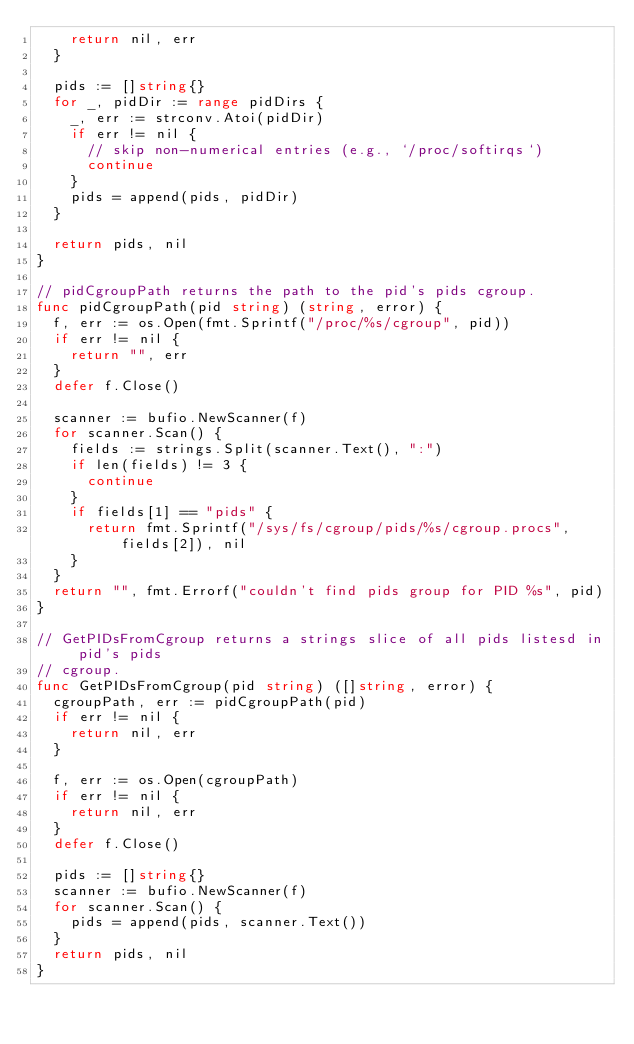<code> <loc_0><loc_0><loc_500><loc_500><_Go_>		return nil, err
	}

	pids := []string{}
	for _, pidDir := range pidDirs {
		_, err := strconv.Atoi(pidDir)
		if err != nil {
			// skip non-numerical entries (e.g., `/proc/softirqs`)
			continue
		}
		pids = append(pids, pidDir)
	}

	return pids, nil
}

// pidCgroupPath returns the path to the pid's pids cgroup.
func pidCgroupPath(pid string) (string, error) {
	f, err := os.Open(fmt.Sprintf("/proc/%s/cgroup", pid))
	if err != nil {
		return "", err
	}
	defer f.Close()

	scanner := bufio.NewScanner(f)
	for scanner.Scan() {
		fields := strings.Split(scanner.Text(), ":")
		if len(fields) != 3 {
			continue
		}
		if fields[1] == "pids" {
			return fmt.Sprintf("/sys/fs/cgroup/pids/%s/cgroup.procs", fields[2]), nil
		}
	}
	return "", fmt.Errorf("couldn't find pids group for PID %s", pid)
}

// GetPIDsFromCgroup returns a strings slice of all pids listesd in pid's pids
// cgroup.
func GetPIDsFromCgroup(pid string) ([]string, error) {
	cgroupPath, err := pidCgroupPath(pid)
	if err != nil {
		return nil, err
	}

	f, err := os.Open(cgroupPath)
	if err != nil {
		return nil, err
	}
	defer f.Close()

	pids := []string{}
	scanner := bufio.NewScanner(f)
	for scanner.Scan() {
		pids = append(pids, scanner.Text())
	}
	return pids, nil
}
</code> 